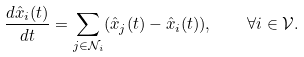Convert formula to latex. <formula><loc_0><loc_0><loc_500><loc_500>\frac { d \hat { x } _ { i } ( t ) } { d t } = \sum _ { j \in \mathcal { N } _ { i } } ( \hat { x } _ { j } ( t ) - \hat { x } _ { i } ( t ) ) , \quad \forall i \in \mathcal { V } .</formula> 